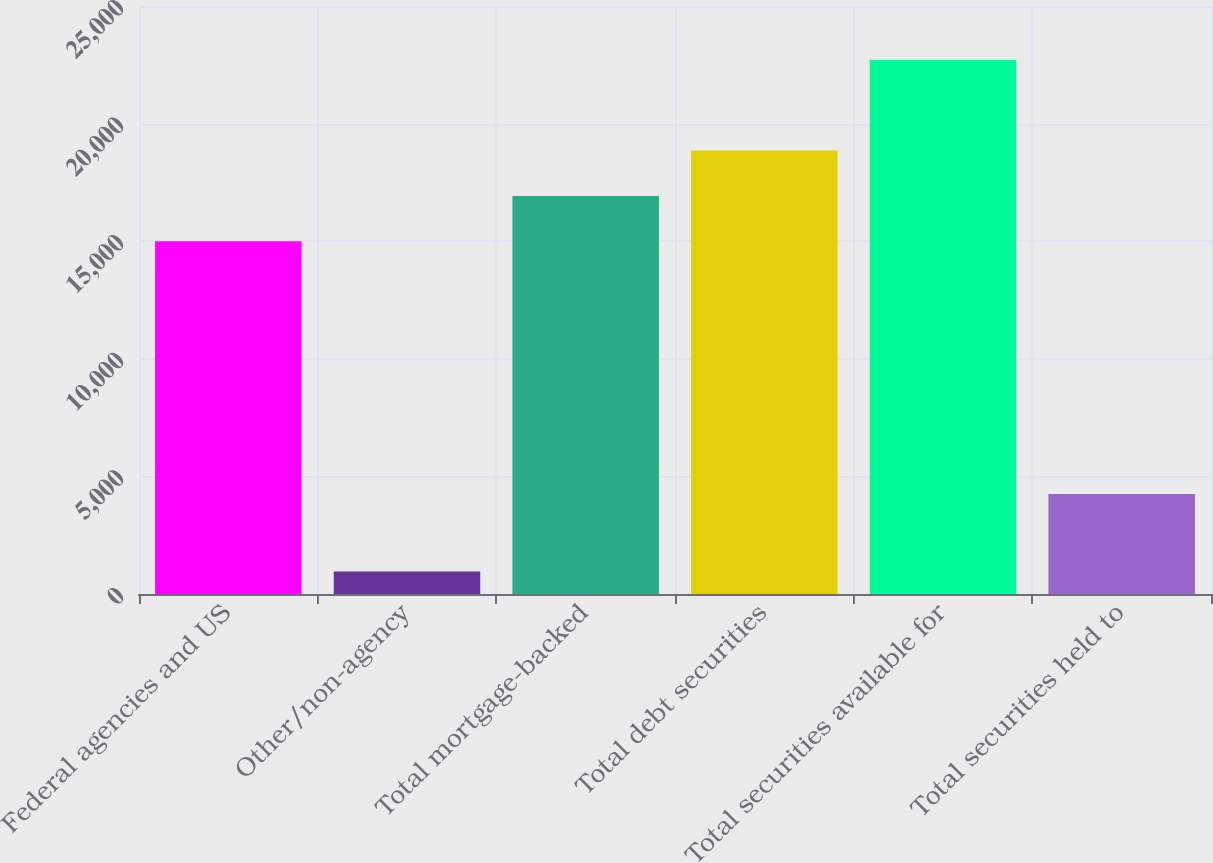Convert chart. <chart><loc_0><loc_0><loc_500><loc_500><bar_chart><fcel>Federal agencies and US<fcel>Other/non-agency<fcel>Total mortgage-backed<fcel>Total debt securities<fcel>Total securities available for<fcel>Total securities held to<nl><fcel>14993<fcel>952<fcel>16923<fcel>18853<fcel>22713<fcel>4257<nl></chart> 